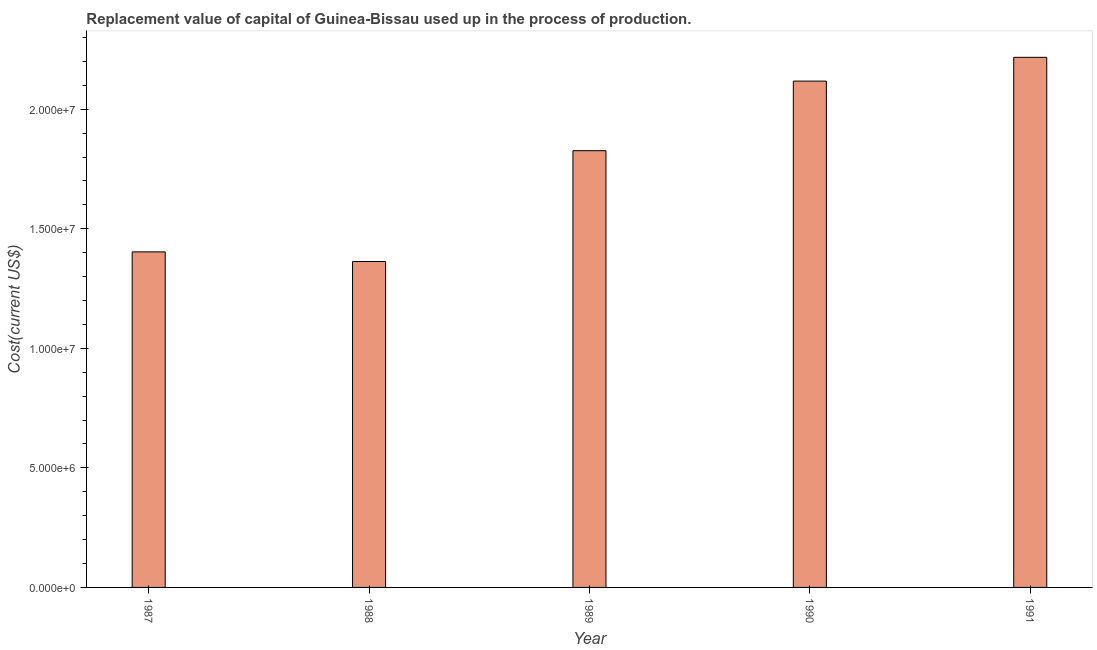Does the graph contain grids?
Your response must be concise. No. What is the title of the graph?
Keep it short and to the point. Replacement value of capital of Guinea-Bissau used up in the process of production. What is the label or title of the X-axis?
Make the answer very short. Year. What is the label or title of the Y-axis?
Keep it short and to the point. Cost(current US$). What is the consumption of fixed capital in 1987?
Ensure brevity in your answer.  1.40e+07. Across all years, what is the maximum consumption of fixed capital?
Make the answer very short. 2.22e+07. Across all years, what is the minimum consumption of fixed capital?
Ensure brevity in your answer.  1.36e+07. In which year was the consumption of fixed capital minimum?
Give a very brief answer. 1988. What is the sum of the consumption of fixed capital?
Offer a terse response. 8.93e+07. What is the difference between the consumption of fixed capital in 1989 and 1990?
Provide a short and direct response. -2.91e+06. What is the average consumption of fixed capital per year?
Your response must be concise. 1.79e+07. What is the median consumption of fixed capital?
Provide a succinct answer. 1.83e+07. In how many years, is the consumption of fixed capital greater than 13000000 US$?
Give a very brief answer. 5. Do a majority of the years between 1987 and 1989 (inclusive) have consumption of fixed capital greater than 1000000 US$?
Your answer should be very brief. Yes. What is the ratio of the consumption of fixed capital in 1989 to that in 1991?
Provide a succinct answer. 0.82. What is the difference between the highest and the second highest consumption of fixed capital?
Offer a very short reply. 9.94e+05. What is the difference between the highest and the lowest consumption of fixed capital?
Offer a terse response. 8.54e+06. In how many years, is the consumption of fixed capital greater than the average consumption of fixed capital taken over all years?
Ensure brevity in your answer.  3. How many bars are there?
Offer a terse response. 5. How many years are there in the graph?
Your response must be concise. 5. What is the difference between two consecutive major ticks on the Y-axis?
Offer a very short reply. 5.00e+06. What is the Cost(current US$) of 1987?
Offer a very short reply. 1.40e+07. What is the Cost(current US$) in 1988?
Offer a very short reply. 1.36e+07. What is the Cost(current US$) in 1989?
Make the answer very short. 1.83e+07. What is the Cost(current US$) of 1990?
Your answer should be very brief. 2.12e+07. What is the Cost(current US$) in 1991?
Provide a succinct answer. 2.22e+07. What is the difference between the Cost(current US$) in 1987 and 1988?
Your answer should be compact. 4.03e+05. What is the difference between the Cost(current US$) in 1987 and 1989?
Provide a short and direct response. -4.23e+06. What is the difference between the Cost(current US$) in 1987 and 1990?
Provide a succinct answer. -7.14e+06. What is the difference between the Cost(current US$) in 1987 and 1991?
Ensure brevity in your answer.  -8.14e+06. What is the difference between the Cost(current US$) in 1988 and 1989?
Keep it short and to the point. -4.64e+06. What is the difference between the Cost(current US$) in 1988 and 1990?
Provide a short and direct response. -7.55e+06. What is the difference between the Cost(current US$) in 1988 and 1991?
Provide a succinct answer. -8.54e+06. What is the difference between the Cost(current US$) in 1989 and 1990?
Give a very brief answer. -2.91e+06. What is the difference between the Cost(current US$) in 1989 and 1991?
Ensure brevity in your answer.  -3.91e+06. What is the difference between the Cost(current US$) in 1990 and 1991?
Offer a terse response. -9.94e+05. What is the ratio of the Cost(current US$) in 1987 to that in 1988?
Your answer should be compact. 1.03. What is the ratio of the Cost(current US$) in 1987 to that in 1989?
Keep it short and to the point. 0.77. What is the ratio of the Cost(current US$) in 1987 to that in 1990?
Ensure brevity in your answer.  0.66. What is the ratio of the Cost(current US$) in 1987 to that in 1991?
Offer a terse response. 0.63. What is the ratio of the Cost(current US$) in 1988 to that in 1989?
Ensure brevity in your answer.  0.75. What is the ratio of the Cost(current US$) in 1988 to that in 1990?
Keep it short and to the point. 0.64. What is the ratio of the Cost(current US$) in 1988 to that in 1991?
Your answer should be very brief. 0.61. What is the ratio of the Cost(current US$) in 1989 to that in 1990?
Provide a succinct answer. 0.86. What is the ratio of the Cost(current US$) in 1989 to that in 1991?
Ensure brevity in your answer.  0.82. What is the ratio of the Cost(current US$) in 1990 to that in 1991?
Offer a terse response. 0.95. 